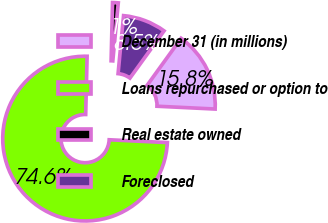Convert chart. <chart><loc_0><loc_0><loc_500><loc_500><pie_chart><fcel>December 31 (in millions)<fcel>Loans repurchased or option to<fcel>Real estate owned<fcel>Foreclosed<nl><fcel>15.81%<fcel>74.62%<fcel>1.11%<fcel>8.46%<nl></chart> 